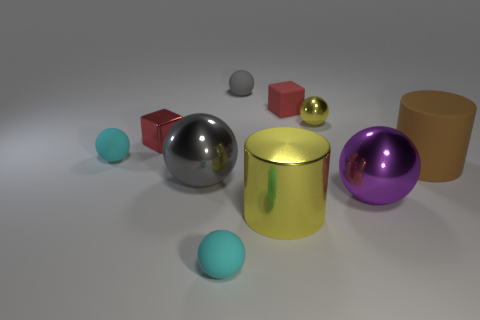Subtract all big balls. How many balls are left? 4 Subtract all brown cylinders. How many cylinders are left? 1 Subtract all cylinders. How many objects are left? 8 Subtract all cyan balls. Subtract all brown cylinders. How many balls are left? 4 Subtract all cyan cylinders. How many brown spheres are left? 0 Subtract all tiny green cubes. Subtract all gray balls. How many objects are left? 8 Add 4 large yellow shiny cylinders. How many large yellow shiny cylinders are left? 5 Add 5 big gray metallic things. How many big gray metallic things exist? 6 Subtract 0 purple cylinders. How many objects are left? 10 Subtract 1 balls. How many balls are left? 5 